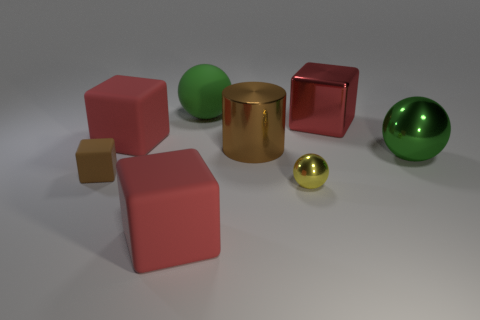Subtract all red blocks. How many were subtracted if there are1red blocks left? 2 Subtract all shiny balls. How many balls are left? 1 Subtract all cyan blocks. How many green balls are left? 2 Subtract 1 spheres. How many spheres are left? 2 Add 1 red matte things. How many objects exist? 9 Subtract all brown cubes. How many cubes are left? 3 Subtract all gray spheres. Subtract all yellow cubes. How many spheres are left? 3 Subtract all cylinders. How many objects are left? 7 Add 1 red rubber balls. How many red rubber balls exist? 1 Subtract 0 cyan blocks. How many objects are left? 8 